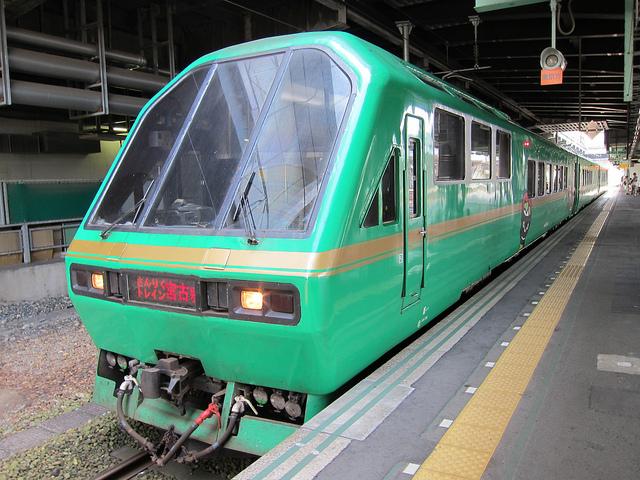What continent is this train most likely on?
Keep it brief. Asia. Is this train's lights on?
Give a very brief answer. Yes. Why is the train stopped?
Give a very brief answer. Loading. 